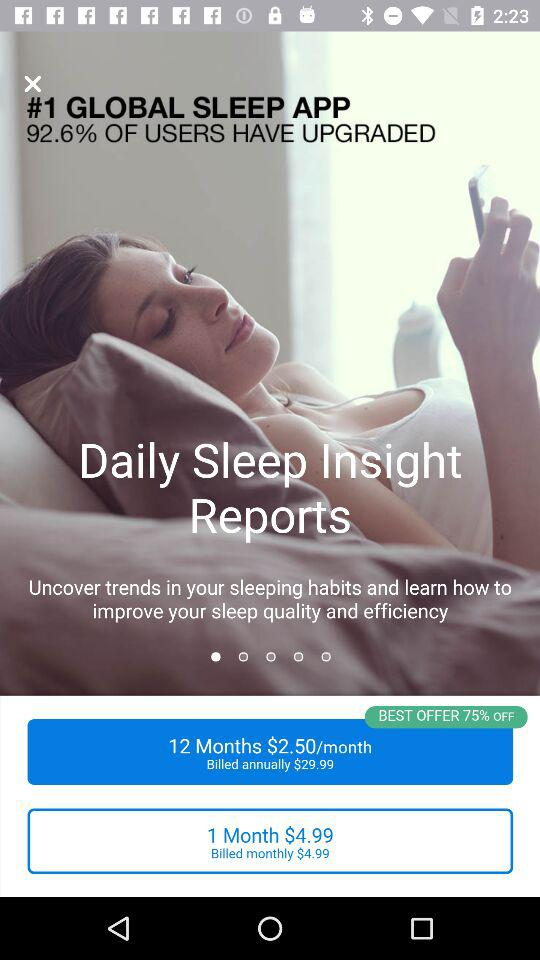What percentage of users upgraded? The percentage is 92.6. 